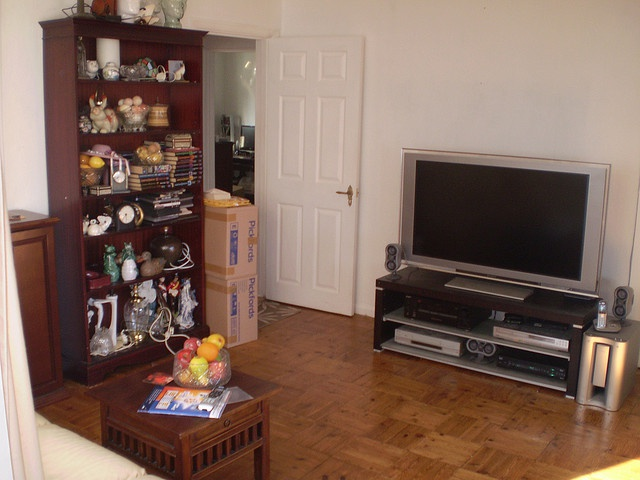Describe the objects in this image and their specific colors. I can see tv in tan, black, darkgray, and gray tones, couch in tan and beige tones, book in tan, lightgray, gray, and darkgray tones, bowl in tan and brown tones, and book in tan, black, maroon, and gray tones in this image. 